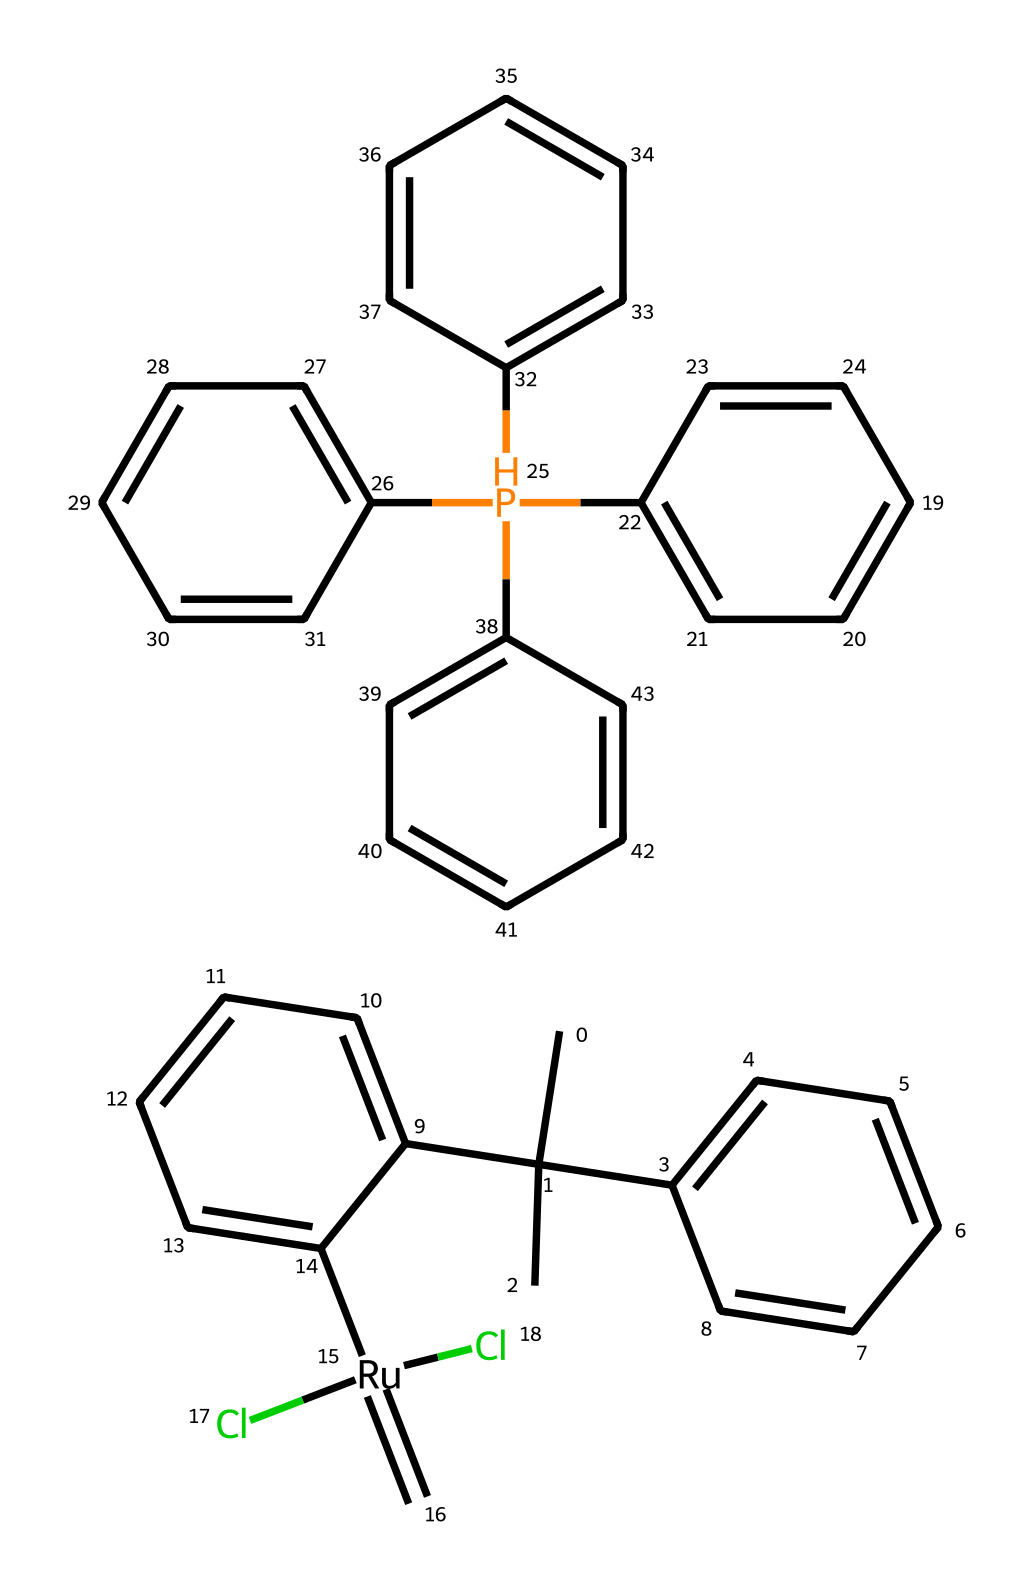What is the central metal in Grubbs' catalyst? The central metal is indicated by the 'Ru' symbol in the structure, which corresponds to ruthenium.
Answer: ruthenium How many chlorine atoms are present in the structure? By examining the structure, there are two Cl elements indicated in the SMILES, meaning there are two chlorine atoms present.
Answer: 2 What type of reaction is Grubbs' catalyst primarily used for? Grubbs' catalyst is primarily used for olefin metathesis, which is a reaction involving the exchange of partners between olefins.
Answer: olefin metathesis What functional groups can be identified in the composition of Grubbs' catalyst? The structure includes both alkenes due to the double bonds in the phenyl groups and chlorinated components, identifiable by the presence of chlorine atoms.
Answer: alkenes and chlorinated components How many aromatic rings can be found in the structure of Grubbs' catalyst? By counting each instance of "C1=CC=CC=C" in the SMILES, it's clear there are four distinct aromatic ring systems present in the structure.
Answer: 4 Which coordination type is indicated by the bond between ruthenium and the chlorine atoms? The bond between ruthenium and chlorine indicates that this is a coordination bond, which shows the interaction between the metal center and ligands.
Answer: coordination bond How many double bonds are found in Grubbs' catalyst? The presence of multiple "=C" notations in the SMILES indicates there are three double bonds in the molecular structure.
Answer: 3 